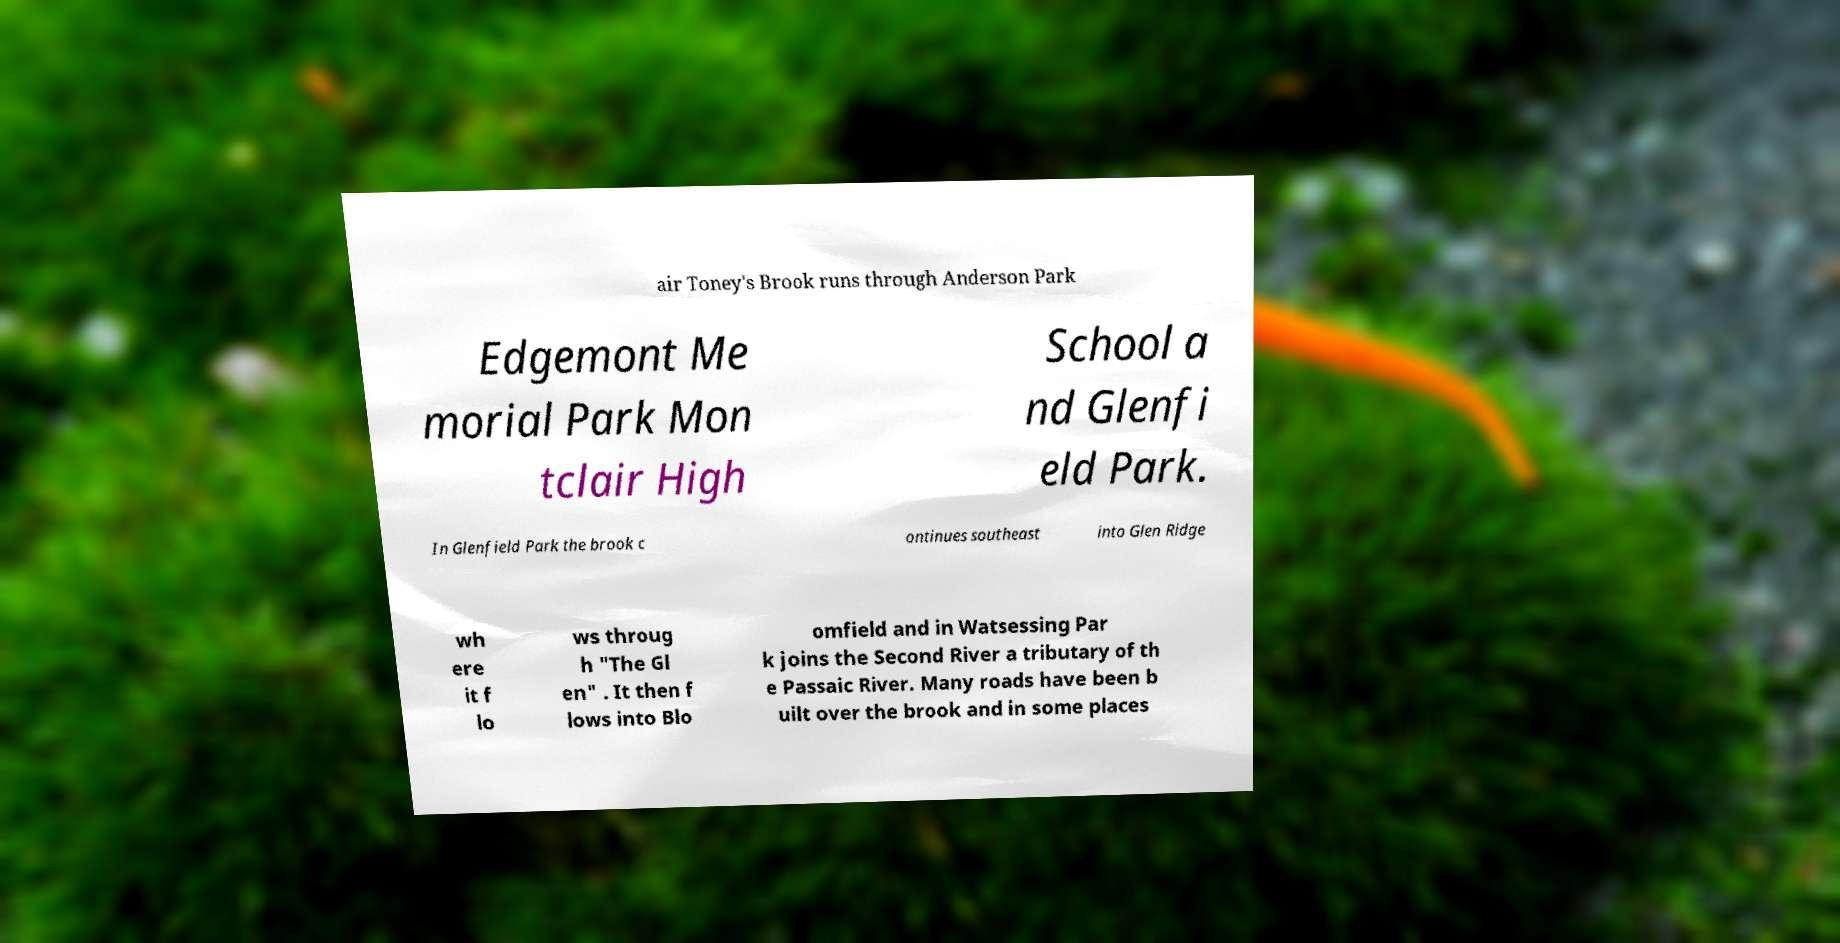Can you read and provide the text displayed in the image?This photo seems to have some interesting text. Can you extract and type it out for me? air Toney's Brook runs through Anderson Park Edgemont Me morial Park Mon tclair High School a nd Glenfi eld Park. In Glenfield Park the brook c ontinues southeast into Glen Ridge wh ere it f lo ws throug h "The Gl en" . It then f lows into Blo omfield and in Watsessing Par k joins the Second River a tributary of th e Passaic River. Many roads have been b uilt over the brook and in some places 